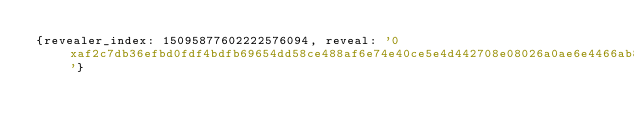<code> <loc_0><loc_0><loc_500><loc_500><_YAML_>{revealer_index: 15095877602222576094, reveal: '0xaf2c7db36efbd0fdf4bdfb69654dd58ce488af6e74e40ce5e4d442708e08026a0ae6e4466ab80c403db3d28e618630b95dd2d5b71a9d0a19efa836e3a5458cebe934adcecbd175676fa76c697d8c44fbbc0afb9249b407c739e4e47a4123fbae'}
</code> 